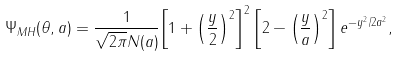Convert formula to latex. <formula><loc_0><loc_0><loc_500><loc_500>\Psi _ { M H } ( \theta , a ) = \frac { 1 } { \sqrt { 2 \pi } N ( a ) } { \left [ 1 + { \left ( \frac { y } { 2 } \right ) } ^ { 2 } \right ] } ^ { 2 } \left [ 2 - { \left ( \frac { y } { a } \right ) } ^ { 2 } \right ] e ^ { - { y } ^ { 2 } / 2 a ^ { 2 } } ,</formula> 